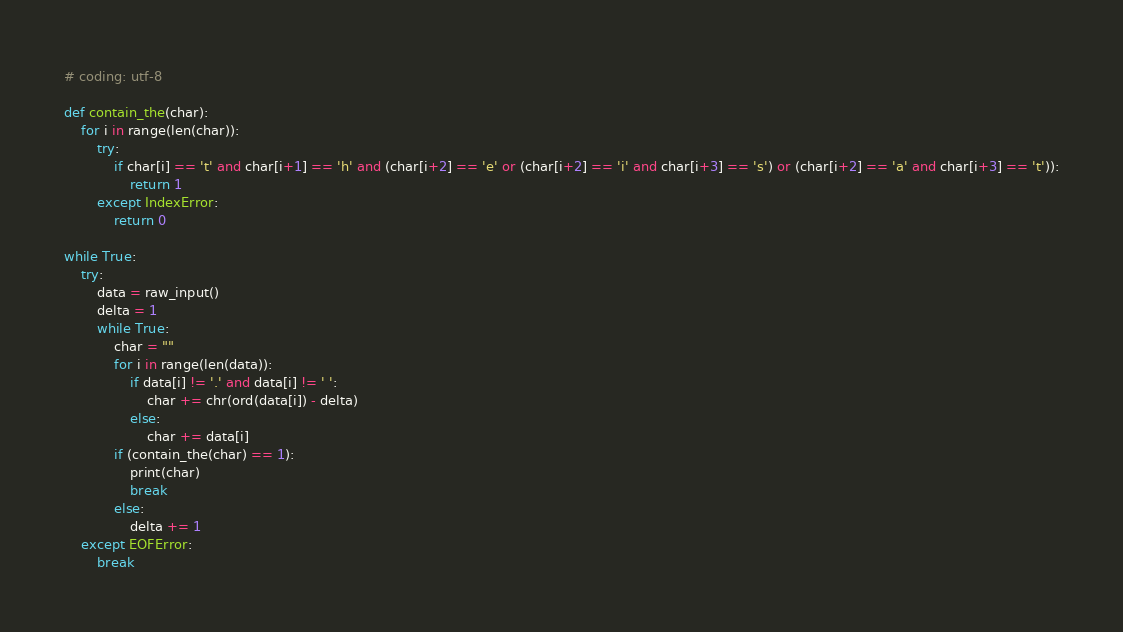<code> <loc_0><loc_0><loc_500><loc_500><_Python_># coding: utf-8

def contain_the(char):
	for i in range(len(char)):
		try:
			if char[i] == 't' and char[i+1] == 'h' and (char[i+2] == 'e' or (char[i+2] == 'i' and char[i+3] == 's') or (char[i+2] == 'a' and char[i+3] == 't')):
				return 1
		except IndexError:
			return 0

while True:
	try:
		data = raw_input()
		delta = 1
		while True:
			char = ""
			for i in range(len(data)):
				if data[i] != '.' and data[i] != ' ':
					char += chr(ord(data[i]) - delta)
				else:
					char += data[i]
			if (contain_the(char) == 1):
				print(char)
				break
			else:
				delta += 1
	except EOFError:
		break
</code> 